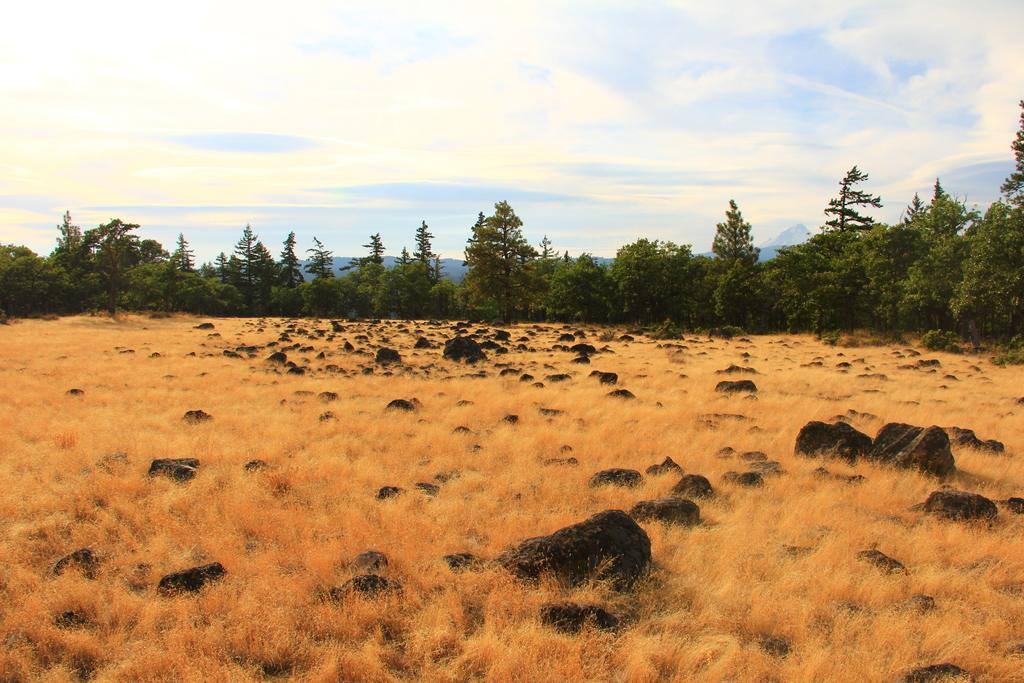What type of vegetation can be seen in the image? There is dried grass in brown color in the image. What other natural elements are visible in the background? There are rocks visible in the background of the image. What type of trees are present in the image? There are trees with green leaves in the image. What colors can be seen in the sky in the image? The sky is a combination of white and blue colors in the image. What type of appliance can be seen in the image? There is no appliance present in the image; it features natural elements such as grass, rocks, trees, and the sky. Is there a volcano visible in the image? There is no volcano present in the image; it features natural elements such as grass, rocks, trees, and the sky. 